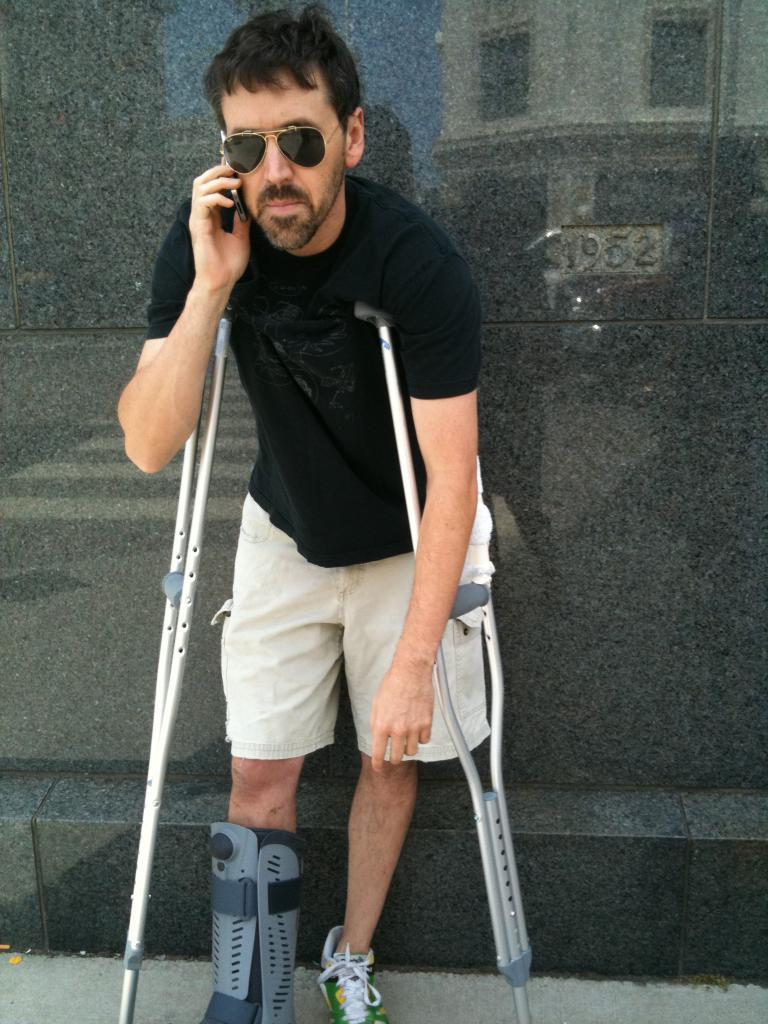What is the person in the image doing with their hand? The person is holding a mobile near their ear. What type of protective eyewear is the person wearing? The person is wearing goggles. What additional equipment can be seen in the image? There are support walking stands in the image. What type of regret can be seen on the person's face in the image? There is no indication of regret on the person's face in the image. How does the person's breath affect the mobile in the image? The person's breath does not affect the mobile in the image, as it is not in close proximity to the person's mouth. 